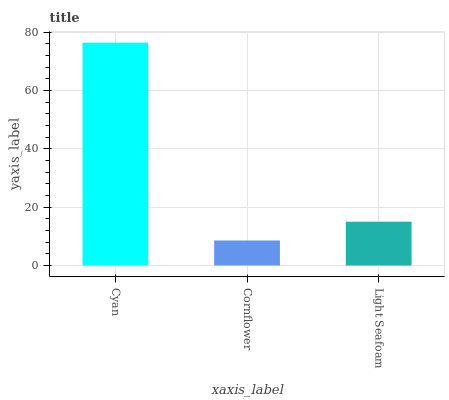Is Light Seafoam the minimum?
Answer yes or no. No. Is Light Seafoam the maximum?
Answer yes or no. No. Is Light Seafoam greater than Cornflower?
Answer yes or no. Yes. Is Cornflower less than Light Seafoam?
Answer yes or no. Yes. Is Cornflower greater than Light Seafoam?
Answer yes or no. No. Is Light Seafoam less than Cornflower?
Answer yes or no. No. Is Light Seafoam the high median?
Answer yes or no. Yes. Is Light Seafoam the low median?
Answer yes or no. Yes. Is Cyan the high median?
Answer yes or no. No. Is Cyan the low median?
Answer yes or no. No. 